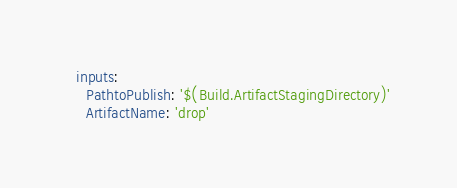Convert code to text. <code><loc_0><loc_0><loc_500><loc_500><_YAML_>  inputs:
    PathtoPublish: '$(Build.ArtifactStagingDirectory)'
    ArtifactName: 'drop'</code> 